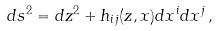<formula> <loc_0><loc_0><loc_500><loc_500>d s ^ { 2 } = d z ^ { 2 } + h _ { i j } ( z , x ) d x ^ { i } d x ^ { j } \, ,</formula> 